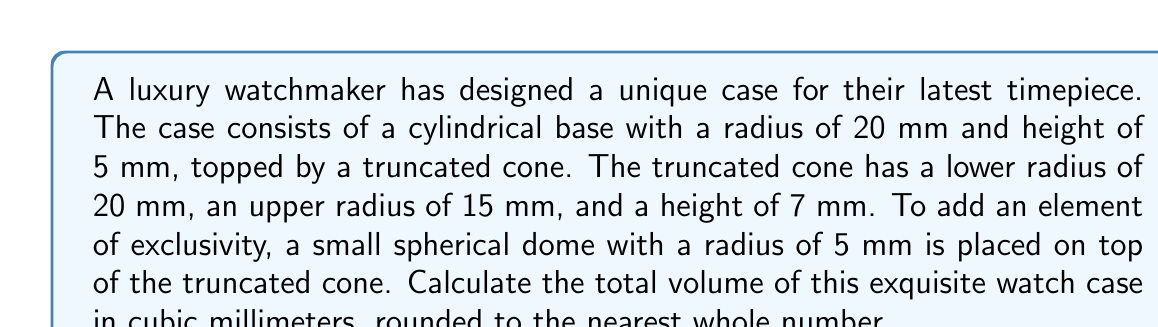Teach me how to tackle this problem. To calculate the total volume, we need to sum the volumes of the three components:

1. Cylindrical base:
   $$V_{cylinder} = \pi r^2 h$$
   $$V_{cylinder} = \pi \cdot 20^2 \cdot 5 = 6283.19 \text{ mm}^3$$

2. Truncated cone:
   $$V_{truncated\_cone} = \frac{1}{3}\pi h(R^2 + r^2 + Rr)$$
   where $R$ is the lower radius, $r$ is the upper radius, and $h$ is the height
   $$V_{truncated\_cone} = \frac{1}{3}\pi \cdot 7(20^2 + 15^2 + 20 \cdot 15) = 7697.69 \text{ mm}^3$$

3. Spherical dome:
   $$V_{sphere} = \frac{4}{3}\pi r^3$$
   $$V_{hemisphere} = \frac{1}{2} \cdot \frac{4}{3}\pi r^3 = \frac{2}{3}\pi r^3$$
   $$V_{hemisphere} = \frac{2}{3}\pi \cdot 5^3 = 261.80 \text{ mm}^3$$

Total volume:
$$V_{total} = V_{cylinder} + V_{truncated\_cone} + V_{hemisphere}$$
$$V_{total} = 6283.19 + 7697.69 + 261.80 = 14242.68 \text{ mm}^3$$

Rounding to the nearest whole number:
$$V_{total} \approx 14243 \text{ mm}^3$$
Answer: 14243 mm³ 